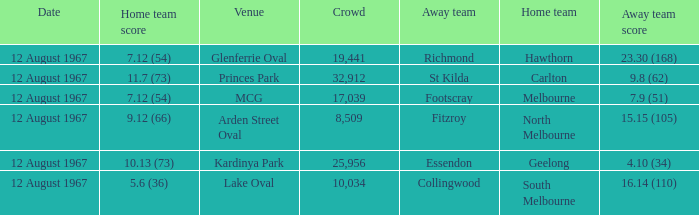What is the date of the game between Melbourne and Footscray? 12 August 1967. 